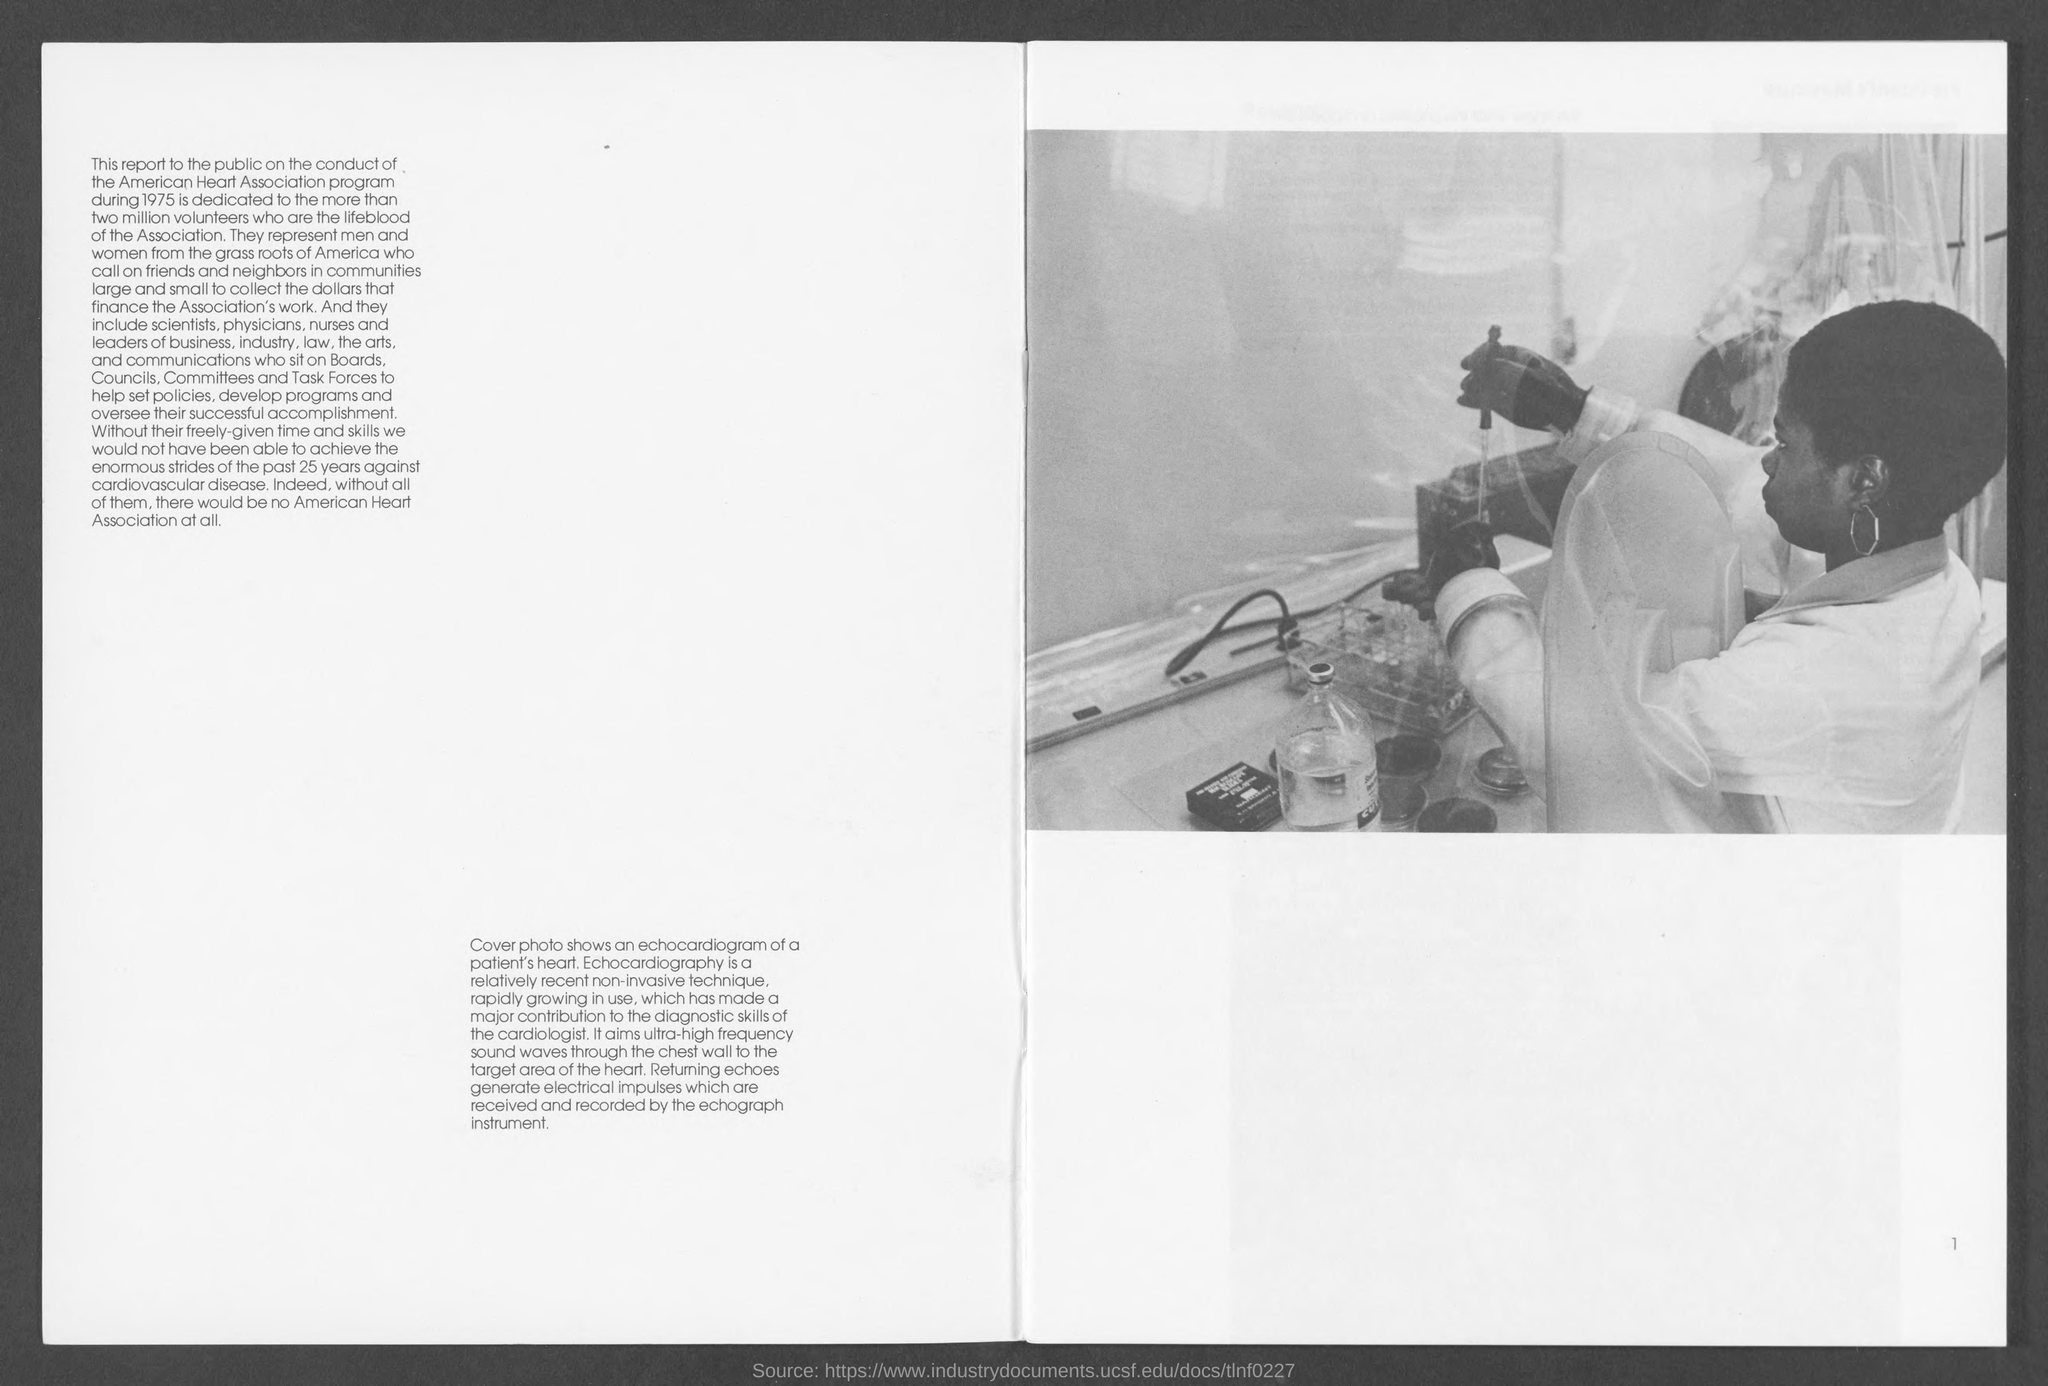Indicate a few pertinent items in this graphic. The number at the bottom-right corner of the page is 1. 